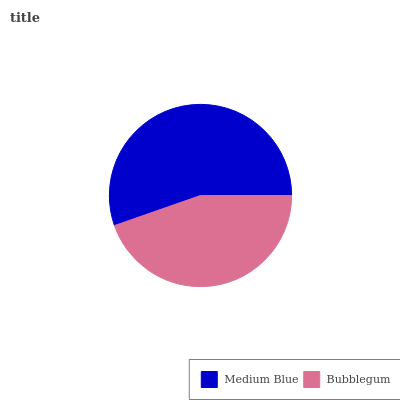Is Bubblegum the minimum?
Answer yes or no. Yes. Is Medium Blue the maximum?
Answer yes or no. Yes. Is Bubblegum the maximum?
Answer yes or no. No. Is Medium Blue greater than Bubblegum?
Answer yes or no. Yes. Is Bubblegum less than Medium Blue?
Answer yes or no. Yes. Is Bubblegum greater than Medium Blue?
Answer yes or no. No. Is Medium Blue less than Bubblegum?
Answer yes or no. No. Is Medium Blue the high median?
Answer yes or no. Yes. Is Bubblegum the low median?
Answer yes or no. Yes. Is Bubblegum the high median?
Answer yes or no. No. Is Medium Blue the low median?
Answer yes or no. No. 